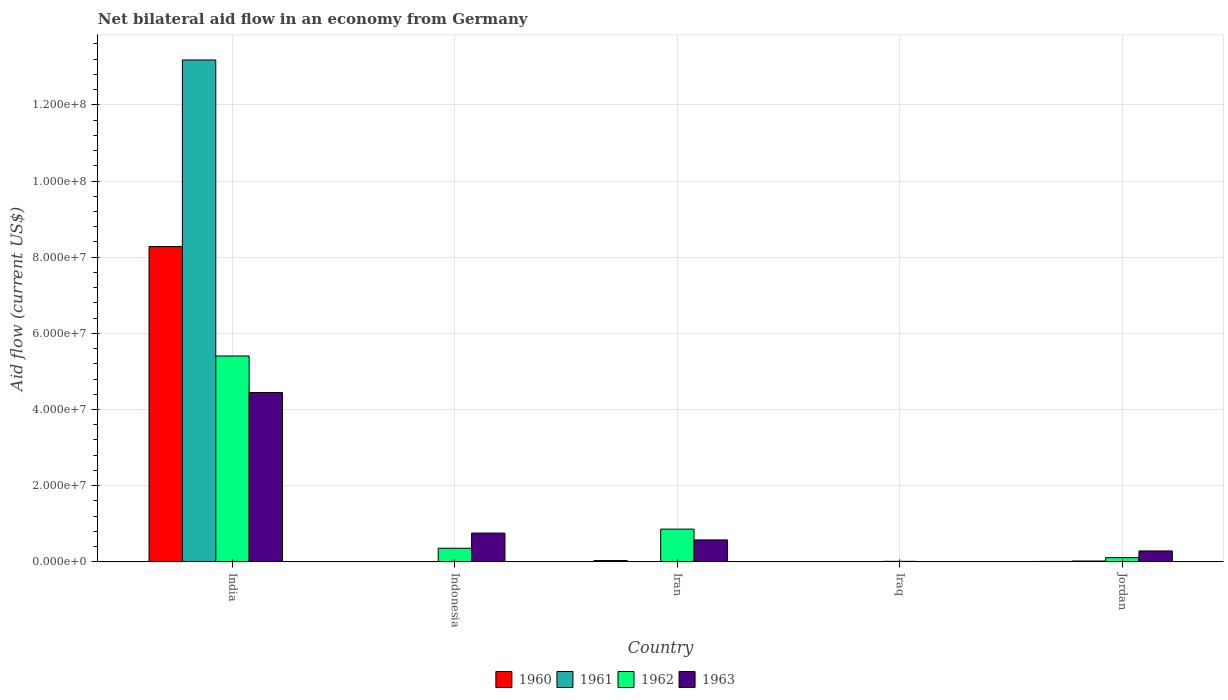How many bars are there on the 5th tick from the left?
Offer a terse response. 4. How many bars are there on the 2nd tick from the right?
Your answer should be very brief. 4. What is the label of the 4th group of bars from the left?
Your response must be concise. Iraq. In how many cases, is the number of bars for a given country not equal to the number of legend labels?
Provide a short and direct response. 1. What is the net bilateral aid flow in 1962 in India?
Provide a succinct answer. 5.41e+07. Across all countries, what is the maximum net bilateral aid flow in 1963?
Offer a very short reply. 4.45e+07. Across all countries, what is the minimum net bilateral aid flow in 1961?
Your response must be concise. 0. What is the total net bilateral aid flow in 1962 in the graph?
Offer a very short reply. 6.75e+07. What is the difference between the net bilateral aid flow in 1963 in India and that in Jordan?
Offer a terse response. 4.16e+07. What is the difference between the net bilateral aid flow in 1963 in Iran and the net bilateral aid flow in 1960 in Indonesia?
Offer a very short reply. 5.76e+06. What is the average net bilateral aid flow in 1960 per country?
Offer a terse response. 1.67e+07. What is the difference between the net bilateral aid flow of/in 1960 and net bilateral aid flow of/in 1962 in India?
Provide a succinct answer. 2.87e+07. What is the ratio of the net bilateral aid flow in 1960 in Iran to that in Jordan?
Your answer should be compact. 2.92. Is the net bilateral aid flow in 1961 in India less than that in Iran?
Keep it short and to the point. No. What is the difference between the highest and the second highest net bilateral aid flow in 1960?
Offer a terse response. 8.24e+07. What is the difference between the highest and the lowest net bilateral aid flow in 1963?
Provide a succinct answer. 4.44e+07. How many countries are there in the graph?
Your answer should be compact. 5. What is the difference between two consecutive major ticks on the Y-axis?
Offer a very short reply. 2.00e+07. How many legend labels are there?
Keep it short and to the point. 4. How are the legend labels stacked?
Your answer should be compact. Horizontal. What is the title of the graph?
Provide a succinct answer. Net bilateral aid flow in an economy from Germany. What is the Aid flow (current US$) in 1960 in India?
Offer a very short reply. 8.28e+07. What is the Aid flow (current US$) in 1961 in India?
Your answer should be very brief. 1.32e+08. What is the Aid flow (current US$) in 1962 in India?
Provide a short and direct response. 5.41e+07. What is the Aid flow (current US$) of 1963 in India?
Provide a short and direct response. 4.45e+07. What is the Aid flow (current US$) of 1962 in Indonesia?
Give a very brief answer. 3.58e+06. What is the Aid flow (current US$) in 1963 in Indonesia?
Give a very brief answer. 7.56e+06. What is the Aid flow (current US$) of 1960 in Iran?
Provide a short and direct response. 3.50e+05. What is the Aid flow (current US$) of 1961 in Iran?
Offer a terse response. 3.00e+04. What is the Aid flow (current US$) in 1962 in Iran?
Provide a short and direct response. 8.60e+06. What is the Aid flow (current US$) in 1963 in Iran?
Give a very brief answer. 5.76e+06. What is the Aid flow (current US$) of 1961 in Iraq?
Offer a very short reply. 2.00e+04. What is the Aid flow (current US$) in 1961 in Jordan?
Provide a succinct answer. 2.30e+05. What is the Aid flow (current US$) in 1962 in Jordan?
Give a very brief answer. 1.11e+06. What is the Aid flow (current US$) of 1963 in Jordan?
Give a very brief answer. 2.87e+06. Across all countries, what is the maximum Aid flow (current US$) in 1960?
Offer a terse response. 8.28e+07. Across all countries, what is the maximum Aid flow (current US$) in 1961?
Keep it short and to the point. 1.32e+08. Across all countries, what is the maximum Aid flow (current US$) in 1962?
Offer a terse response. 5.41e+07. Across all countries, what is the maximum Aid flow (current US$) of 1963?
Ensure brevity in your answer.  4.45e+07. Across all countries, what is the minimum Aid flow (current US$) of 1960?
Ensure brevity in your answer.  0. Across all countries, what is the minimum Aid flow (current US$) of 1962?
Your answer should be compact. 1.40e+05. What is the total Aid flow (current US$) in 1960 in the graph?
Keep it short and to the point. 8.33e+07. What is the total Aid flow (current US$) of 1961 in the graph?
Give a very brief answer. 1.32e+08. What is the total Aid flow (current US$) of 1962 in the graph?
Provide a short and direct response. 6.75e+07. What is the total Aid flow (current US$) of 1963 in the graph?
Offer a terse response. 6.07e+07. What is the difference between the Aid flow (current US$) of 1962 in India and that in Indonesia?
Offer a very short reply. 5.05e+07. What is the difference between the Aid flow (current US$) of 1963 in India and that in Indonesia?
Give a very brief answer. 3.69e+07. What is the difference between the Aid flow (current US$) in 1960 in India and that in Iran?
Offer a terse response. 8.24e+07. What is the difference between the Aid flow (current US$) in 1961 in India and that in Iran?
Your response must be concise. 1.32e+08. What is the difference between the Aid flow (current US$) of 1962 in India and that in Iran?
Give a very brief answer. 4.55e+07. What is the difference between the Aid flow (current US$) in 1963 in India and that in Iran?
Provide a short and direct response. 3.87e+07. What is the difference between the Aid flow (current US$) in 1960 in India and that in Iraq?
Keep it short and to the point. 8.27e+07. What is the difference between the Aid flow (current US$) of 1961 in India and that in Iraq?
Offer a very short reply. 1.32e+08. What is the difference between the Aid flow (current US$) in 1962 in India and that in Iraq?
Your response must be concise. 5.39e+07. What is the difference between the Aid flow (current US$) in 1963 in India and that in Iraq?
Keep it short and to the point. 4.44e+07. What is the difference between the Aid flow (current US$) in 1960 in India and that in Jordan?
Keep it short and to the point. 8.27e+07. What is the difference between the Aid flow (current US$) in 1961 in India and that in Jordan?
Make the answer very short. 1.32e+08. What is the difference between the Aid flow (current US$) of 1962 in India and that in Jordan?
Make the answer very short. 5.30e+07. What is the difference between the Aid flow (current US$) in 1963 in India and that in Jordan?
Offer a very short reply. 4.16e+07. What is the difference between the Aid flow (current US$) of 1962 in Indonesia and that in Iran?
Your answer should be compact. -5.02e+06. What is the difference between the Aid flow (current US$) of 1963 in Indonesia and that in Iran?
Offer a terse response. 1.80e+06. What is the difference between the Aid flow (current US$) in 1962 in Indonesia and that in Iraq?
Make the answer very short. 3.44e+06. What is the difference between the Aid flow (current US$) of 1963 in Indonesia and that in Iraq?
Make the answer very short. 7.47e+06. What is the difference between the Aid flow (current US$) of 1962 in Indonesia and that in Jordan?
Give a very brief answer. 2.47e+06. What is the difference between the Aid flow (current US$) of 1963 in Indonesia and that in Jordan?
Provide a short and direct response. 4.69e+06. What is the difference between the Aid flow (current US$) of 1962 in Iran and that in Iraq?
Offer a very short reply. 8.46e+06. What is the difference between the Aid flow (current US$) of 1963 in Iran and that in Iraq?
Provide a short and direct response. 5.67e+06. What is the difference between the Aid flow (current US$) in 1960 in Iran and that in Jordan?
Ensure brevity in your answer.  2.30e+05. What is the difference between the Aid flow (current US$) in 1961 in Iran and that in Jordan?
Provide a short and direct response. -2.00e+05. What is the difference between the Aid flow (current US$) in 1962 in Iran and that in Jordan?
Give a very brief answer. 7.49e+06. What is the difference between the Aid flow (current US$) of 1963 in Iran and that in Jordan?
Your answer should be very brief. 2.89e+06. What is the difference between the Aid flow (current US$) of 1960 in Iraq and that in Jordan?
Provide a short and direct response. -6.00e+04. What is the difference between the Aid flow (current US$) in 1961 in Iraq and that in Jordan?
Your answer should be very brief. -2.10e+05. What is the difference between the Aid flow (current US$) in 1962 in Iraq and that in Jordan?
Provide a short and direct response. -9.70e+05. What is the difference between the Aid flow (current US$) in 1963 in Iraq and that in Jordan?
Provide a succinct answer. -2.78e+06. What is the difference between the Aid flow (current US$) of 1960 in India and the Aid flow (current US$) of 1962 in Indonesia?
Give a very brief answer. 7.92e+07. What is the difference between the Aid flow (current US$) of 1960 in India and the Aid flow (current US$) of 1963 in Indonesia?
Your answer should be compact. 7.52e+07. What is the difference between the Aid flow (current US$) of 1961 in India and the Aid flow (current US$) of 1962 in Indonesia?
Provide a short and direct response. 1.28e+08. What is the difference between the Aid flow (current US$) in 1961 in India and the Aid flow (current US$) in 1963 in Indonesia?
Make the answer very short. 1.24e+08. What is the difference between the Aid flow (current US$) in 1962 in India and the Aid flow (current US$) in 1963 in Indonesia?
Give a very brief answer. 4.65e+07. What is the difference between the Aid flow (current US$) in 1960 in India and the Aid flow (current US$) in 1961 in Iran?
Offer a terse response. 8.28e+07. What is the difference between the Aid flow (current US$) of 1960 in India and the Aid flow (current US$) of 1962 in Iran?
Offer a terse response. 7.42e+07. What is the difference between the Aid flow (current US$) in 1960 in India and the Aid flow (current US$) in 1963 in Iran?
Your answer should be compact. 7.70e+07. What is the difference between the Aid flow (current US$) in 1961 in India and the Aid flow (current US$) in 1962 in Iran?
Provide a short and direct response. 1.23e+08. What is the difference between the Aid flow (current US$) in 1961 in India and the Aid flow (current US$) in 1963 in Iran?
Offer a very short reply. 1.26e+08. What is the difference between the Aid flow (current US$) in 1962 in India and the Aid flow (current US$) in 1963 in Iran?
Provide a succinct answer. 4.83e+07. What is the difference between the Aid flow (current US$) of 1960 in India and the Aid flow (current US$) of 1961 in Iraq?
Ensure brevity in your answer.  8.28e+07. What is the difference between the Aid flow (current US$) of 1960 in India and the Aid flow (current US$) of 1962 in Iraq?
Your answer should be very brief. 8.26e+07. What is the difference between the Aid flow (current US$) of 1960 in India and the Aid flow (current US$) of 1963 in Iraq?
Provide a succinct answer. 8.27e+07. What is the difference between the Aid flow (current US$) in 1961 in India and the Aid flow (current US$) in 1962 in Iraq?
Offer a terse response. 1.32e+08. What is the difference between the Aid flow (current US$) of 1961 in India and the Aid flow (current US$) of 1963 in Iraq?
Ensure brevity in your answer.  1.32e+08. What is the difference between the Aid flow (current US$) in 1962 in India and the Aid flow (current US$) in 1963 in Iraq?
Your answer should be very brief. 5.40e+07. What is the difference between the Aid flow (current US$) of 1960 in India and the Aid flow (current US$) of 1961 in Jordan?
Your answer should be very brief. 8.26e+07. What is the difference between the Aid flow (current US$) of 1960 in India and the Aid flow (current US$) of 1962 in Jordan?
Your answer should be compact. 8.17e+07. What is the difference between the Aid flow (current US$) in 1960 in India and the Aid flow (current US$) in 1963 in Jordan?
Offer a terse response. 7.99e+07. What is the difference between the Aid flow (current US$) of 1961 in India and the Aid flow (current US$) of 1962 in Jordan?
Provide a succinct answer. 1.31e+08. What is the difference between the Aid flow (current US$) in 1961 in India and the Aid flow (current US$) in 1963 in Jordan?
Offer a very short reply. 1.29e+08. What is the difference between the Aid flow (current US$) in 1962 in India and the Aid flow (current US$) in 1963 in Jordan?
Make the answer very short. 5.12e+07. What is the difference between the Aid flow (current US$) in 1962 in Indonesia and the Aid flow (current US$) in 1963 in Iran?
Make the answer very short. -2.18e+06. What is the difference between the Aid flow (current US$) in 1962 in Indonesia and the Aid flow (current US$) in 1963 in Iraq?
Your answer should be compact. 3.49e+06. What is the difference between the Aid flow (current US$) of 1962 in Indonesia and the Aid flow (current US$) of 1963 in Jordan?
Keep it short and to the point. 7.10e+05. What is the difference between the Aid flow (current US$) of 1960 in Iran and the Aid flow (current US$) of 1961 in Iraq?
Your answer should be compact. 3.30e+05. What is the difference between the Aid flow (current US$) of 1960 in Iran and the Aid flow (current US$) of 1962 in Iraq?
Keep it short and to the point. 2.10e+05. What is the difference between the Aid flow (current US$) in 1962 in Iran and the Aid flow (current US$) in 1963 in Iraq?
Offer a very short reply. 8.51e+06. What is the difference between the Aid flow (current US$) of 1960 in Iran and the Aid flow (current US$) of 1962 in Jordan?
Offer a very short reply. -7.60e+05. What is the difference between the Aid flow (current US$) of 1960 in Iran and the Aid flow (current US$) of 1963 in Jordan?
Provide a short and direct response. -2.52e+06. What is the difference between the Aid flow (current US$) of 1961 in Iran and the Aid flow (current US$) of 1962 in Jordan?
Your answer should be compact. -1.08e+06. What is the difference between the Aid flow (current US$) in 1961 in Iran and the Aid flow (current US$) in 1963 in Jordan?
Provide a short and direct response. -2.84e+06. What is the difference between the Aid flow (current US$) of 1962 in Iran and the Aid flow (current US$) of 1963 in Jordan?
Your answer should be very brief. 5.73e+06. What is the difference between the Aid flow (current US$) of 1960 in Iraq and the Aid flow (current US$) of 1961 in Jordan?
Keep it short and to the point. -1.70e+05. What is the difference between the Aid flow (current US$) of 1960 in Iraq and the Aid flow (current US$) of 1962 in Jordan?
Offer a very short reply. -1.05e+06. What is the difference between the Aid flow (current US$) of 1960 in Iraq and the Aid flow (current US$) of 1963 in Jordan?
Your response must be concise. -2.81e+06. What is the difference between the Aid flow (current US$) of 1961 in Iraq and the Aid flow (current US$) of 1962 in Jordan?
Ensure brevity in your answer.  -1.09e+06. What is the difference between the Aid flow (current US$) of 1961 in Iraq and the Aid flow (current US$) of 1963 in Jordan?
Your answer should be compact. -2.85e+06. What is the difference between the Aid flow (current US$) of 1962 in Iraq and the Aid flow (current US$) of 1963 in Jordan?
Make the answer very short. -2.73e+06. What is the average Aid flow (current US$) in 1960 per country?
Ensure brevity in your answer.  1.67e+07. What is the average Aid flow (current US$) of 1961 per country?
Your response must be concise. 2.64e+07. What is the average Aid flow (current US$) of 1962 per country?
Your response must be concise. 1.35e+07. What is the average Aid flow (current US$) of 1963 per country?
Give a very brief answer. 1.21e+07. What is the difference between the Aid flow (current US$) of 1960 and Aid flow (current US$) of 1961 in India?
Keep it short and to the point. -4.90e+07. What is the difference between the Aid flow (current US$) in 1960 and Aid flow (current US$) in 1962 in India?
Your answer should be very brief. 2.87e+07. What is the difference between the Aid flow (current US$) in 1960 and Aid flow (current US$) in 1963 in India?
Give a very brief answer. 3.83e+07. What is the difference between the Aid flow (current US$) of 1961 and Aid flow (current US$) of 1962 in India?
Offer a terse response. 7.77e+07. What is the difference between the Aid flow (current US$) of 1961 and Aid flow (current US$) of 1963 in India?
Provide a short and direct response. 8.73e+07. What is the difference between the Aid flow (current US$) of 1962 and Aid flow (current US$) of 1963 in India?
Provide a succinct answer. 9.60e+06. What is the difference between the Aid flow (current US$) of 1962 and Aid flow (current US$) of 1963 in Indonesia?
Make the answer very short. -3.98e+06. What is the difference between the Aid flow (current US$) in 1960 and Aid flow (current US$) in 1962 in Iran?
Give a very brief answer. -8.25e+06. What is the difference between the Aid flow (current US$) of 1960 and Aid flow (current US$) of 1963 in Iran?
Provide a succinct answer. -5.41e+06. What is the difference between the Aid flow (current US$) in 1961 and Aid flow (current US$) in 1962 in Iran?
Ensure brevity in your answer.  -8.57e+06. What is the difference between the Aid flow (current US$) of 1961 and Aid flow (current US$) of 1963 in Iran?
Offer a terse response. -5.73e+06. What is the difference between the Aid flow (current US$) in 1962 and Aid flow (current US$) in 1963 in Iran?
Your answer should be compact. 2.84e+06. What is the difference between the Aid flow (current US$) in 1960 and Aid flow (current US$) in 1962 in Iraq?
Make the answer very short. -8.00e+04. What is the difference between the Aid flow (current US$) of 1961 and Aid flow (current US$) of 1962 in Iraq?
Keep it short and to the point. -1.20e+05. What is the difference between the Aid flow (current US$) in 1962 and Aid flow (current US$) in 1963 in Iraq?
Your answer should be very brief. 5.00e+04. What is the difference between the Aid flow (current US$) of 1960 and Aid flow (current US$) of 1962 in Jordan?
Keep it short and to the point. -9.90e+05. What is the difference between the Aid flow (current US$) of 1960 and Aid flow (current US$) of 1963 in Jordan?
Make the answer very short. -2.75e+06. What is the difference between the Aid flow (current US$) in 1961 and Aid flow (current US$) in 1962 in Jordan?
Offer a terse response. -8.80e+05. What is the difference between the Aid flow (current US$) of 1961 and Aid flow (current US$) of 1963 in Jordan?
Make the answer very short. -2.64e+06. What is the difference between the Aid flow (current US$) of 1962 and Aid flow (current US$) of 1963 in Jordan?
Provide a short and direct response. -1.76e+06. What is the ratio of the Aid flow (current US$) of 1962 in India to that in Indonesia?
Provide a short and direct response. 15.1. What is the ratio of the Aid flow (current US$) in 1963 in India to that in Indonesia?
Offer a very short reply. 5.88. What is the ratio of the Aid flow (current US$) of 1960 in India to that in Iran?
Make the answer very short. 236.54. What is the ratio of the Aid flow (current US$) in 1961 in India to that in Iran?
Offer a very short reply. 4392.67. What is the ratio of the Aid flow (current US$) of 1962 in India to that in Iran?
Offer a very short reply. 6.29. What is the ratio of the Aid flow (current US$) of 1963 in India to that in Iran?
Make the answer very short. 7.72. What is the ratio of the Aid flow (current US$) of 1960 in India to that in Iraq?
Give a very brief answer. 1379.83. What is the ratio of the Aid flow (current US$) in 1961 in India to that in Iraq?
Offer a very short reply. 6589. What is the ratio of the Aid flow (current US$) in 1962 in India to that in Iraq?
Make the answer very short. 386.14. What is the ratio of the Aid flow (current US$) of 1963 in India to that in Iraq?
Your answer should be compact. 494. What is the ratio of the Aid flow (current US$) in 1960 in India to that in Jordan?
Your answer should be compact. 689.92. What is the ratio of the Aid flow (current US$) in 1961 in India to that in Jordan?
Ensure brevity in your answer.  572.96. What is the ratio of the Aid flow (current US$) in 1962 in India to that in Jordan?
Offer a terse response. 48.7. What is the ratio of the Aid flow (current US$) of 1963 in India to that in Jordan?
Give a very brief answer. 15.49. What is the ratio of the Aid flow (current US$) of 1962 in Indonesia to that in Iran?
Provide a short and direct response. 0.42. What is the ratio of the Aid flow (current US$) in 1963 in Indonesia to that in Iran?
Give a very brief answer. 1.31. What is the ratio of the Aid flow (current US$) in 1962 in Indonesia to that in Iraq?
Your answer should be compact. 25.57. What is the ratio of the Aid flow (current US$) of 1962 in Indonesia to that in Jordan?
Give a very brief answer. 3.23. What is the ratio of the Aid flow (current US$) in 1963 in Indonesia to that in Jordan?
Make the answer very short. 2.63. What is the ratio of the Aid flow (current US$) in 1960 in Iran to that in Iraq?
Your response must be concise. 5.83. What is the ratio of the Aid flow (current US$) in 1961 in Iran to that in Iraq?
Make the answer very short. 1.5. What is the ratio of the Aid flow (current US$) in 1962 in Iran to that in Iraq?
Offer a very short reply. 61.43. What is the ratio of the Aid flow (current US$) in 1960 in Iran to that in Jordan?
Make the answer very short. 2.92. What is the ratio of the Aid flow (current US$) in 1961 in Iran to that in Jordan?
Keep it short and to the point. 0.13. What is the ratio of the Aid flow (current US$) in 1962 in Iran to that in Jordan?
Keep it short and to the point. 7.75. What is the ratio of the Aid flow (current US$) of 1963 in Iran to that in Jordan?
Provide a short and direct response. 2.01. What is the ratio of the Aid flow (current US$) of 1961 in Iraq to that in Jordan?
Offer a very short reply. 0.09. What is the ratio of the Aid flow (current US$) in 1962 in Iraq to that in Jordan?
Provide a short and direct response. 0.13. What is the ratio of the Aid flow (current US$) in 1963 in Iraq to that in Jordan?
Offer a terse response. 0.03. What is the difference between the highest and the second highest Aid flow (current US$) of 1960?
Provide a succinct answer. 8.24e+07. What is the difference between the highest and the second highest Aid flow (current US$) of 1961?
Provide a succinct answer. 1.32e+08. What is the difference between the highest and the second highest Aid flow (current US$) in 1962?
Offer a terse response. 4.55e+07. What is the difference between the highest and the second highest Aid flow (current US$) of 1963?
Provide a short and direct response. 3.69e+07. What is the difference between the highest and the lowest Aid flow (current US$) in 1960?
Make the answer very short. 8.28e+07. What is the difference between the highest and the lowest Aid flow (current US$) of 1961?
Keep it short and to the point. 1.32e+08. What is the difference between the highest and the lowest Aid flow (current US$) of 1962?
Give a very brief answer. 5.39e+07. What is the difference between the highest and the lowest Aid flow (current US$) of 1963?
Offer a terse response. 4.44e+07. 